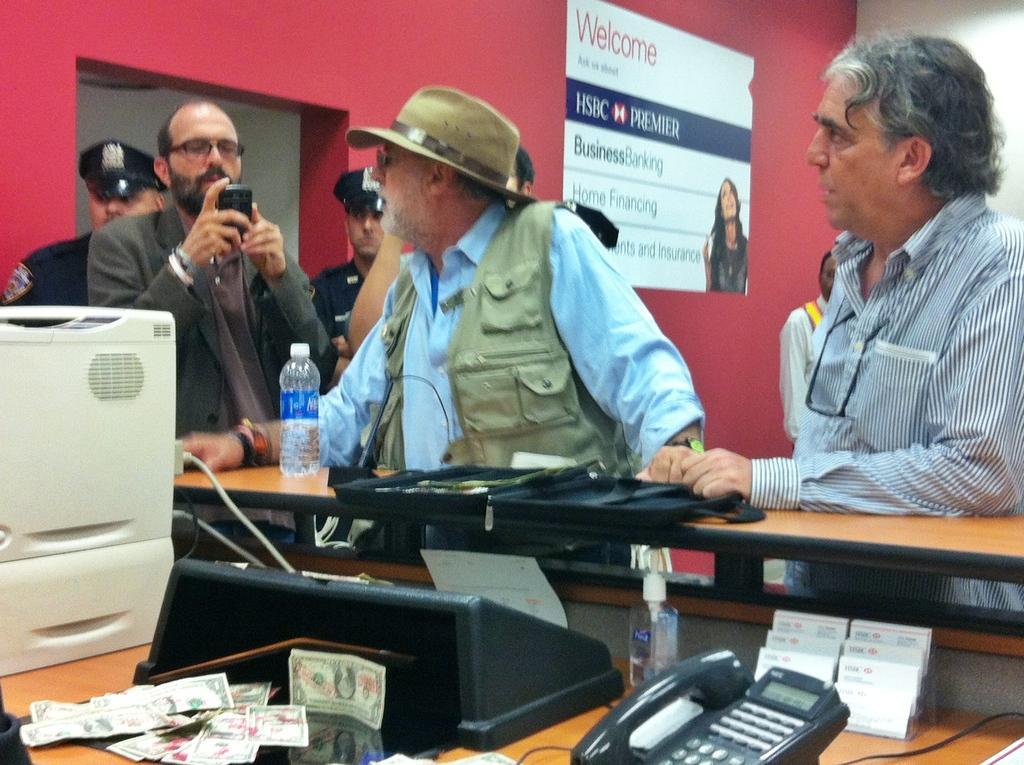Could you give a brief overview of what you see in this image? In this picture we can see a group of people standing, jackets, caps, bottles, spectacles, mobile, telephone, machines, notes, poster on the wall and some objects. 